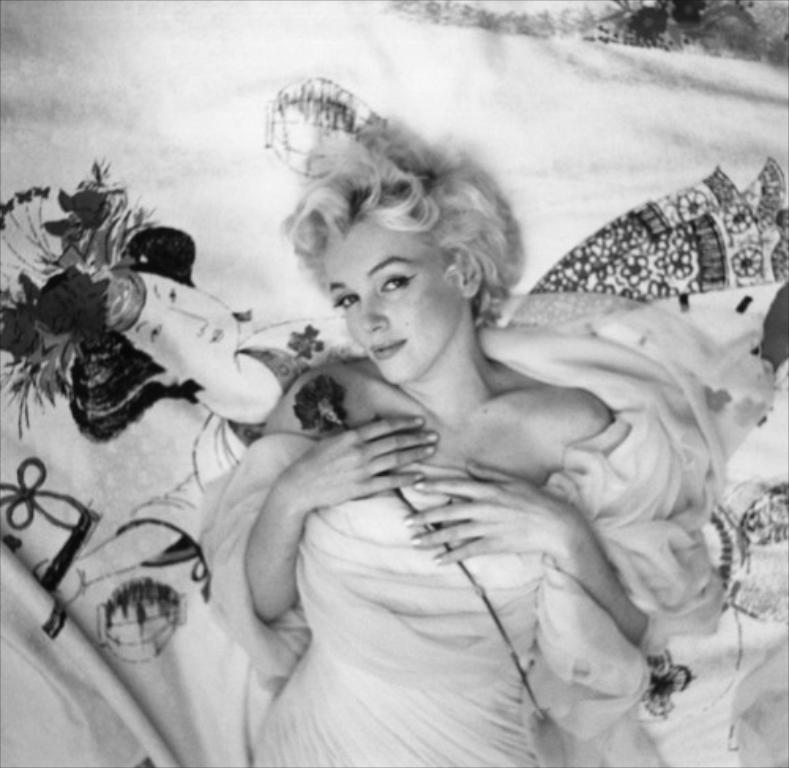Who is present in the image? There is a woman in the image. What is the woman doing in the image? The woman is lying down. What object is the woman holding in the image? The woman is holding a flower. What is at the bottom of the image? There is a cloth at the bottom of the image. What design is on the cloth? The cloth has a design of a person. What is the color scheme of the image? The image is in black and white. What type of plant can be seen growing in the image? There is no plant visible in the image. Is there any rain falling in the image? There is no rain present in the image. 